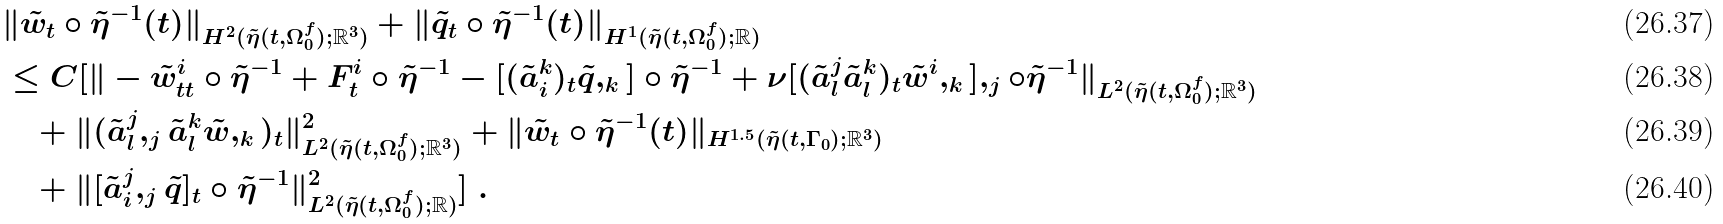Convert formula to latex. <formula><loc_0><loc_0><loc_500><loc_500>& \| \tilde { w } _ { t } \circ \tilde { \eta } ^ { - 1 } ( t ) \| _ { H ^ { 2 } ( \tilde { \eta } ( t , \Omega _ { 0 } ^ { f } ) ; { \mathbb { R } } ^ { 3 } ) } + \| \tilde { q } _ { t } \circ \tilde { \eta } ^ { - 1 } ( t ) \| _ { H ^ { 1 } ( \tilde { \eta } ( t , \Omega _ { 0 } ^ { f } ) ; { \mathbb { R } } ) } \\ & \leq C [ \| - \tilde { w } ^ { i } _ { t t } \circ \tilde { \eta } ^ { - 1 } + F ^ { i } _ { t } \circ \tilde { \eta } ^ { - 1 } - [ ( \tilde { a } _ { i } ^ { k } ) _ { t } \tilde { q } , _ { k } ] \circ { \tilde { \eta } } ^ { - 1 } + \nu [ ( \tilde { a } _ { l } ^ { j } \tilde { a } _ { l } ^ { k } ) _ { t } \tilde { w } ^ { i } , _ { k } ] , _ { j } \circ { \tilde { \eta } } ^ { - 1 } \| _ { L ^ { 2 } ( \tilde { \eta } ( t , \Omega _ { 0 } ^ { f } ) ; { \mathbb { R } } ^ { 3 } ) } \\ & \quad + \| ( \tilde { a } _ { l } ^ { j } , _ { j } \tilde { a } _ { l } ^ { k } \tilde { w } , _ { k } ) _ { t } \| ^ { 2 } _ { L ^ { 2 } ( \tilde { \eta } ( t , \Omega _ { 0 } ^ { f } ) ; { \mathbb { R } } ^ { 3 } ) } + \| \tilde { w } _ { t } \circ \tilde { \eta } ^ { - 1 } ( t ) \| _ { H ^ { 1 . 5 } ( \tilde { \eta } ( t , \Gamma _ { 0 } ) ; { \mathbb { R } } ^ { 3 } ) } \\ & \quad + \| [ \tilde { a } _ { i } ^ { j } , _ { j } \tilde { q } ] _ { t } \circ \tilde { \eta } ^ { - 1 } \| ^ { 2 } _ { L ^ { 2 } ( \tilde { \eta } ( t , \Omega _ { 0 } ^ { f } ) ; { \mathbb { R } } ) } ] \ .</formula> 